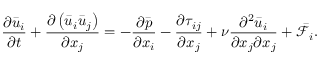<formula> <loc_0><loc_0><loc_500><loc_500>\frac { \partial { { { \bar { u } } } _ { i } } } { \partial t } + \frac { \partial \left ( { { { \bar { u } } } _ { i } } { { { \bar { u } } } _ { j } } \right ) } { \partial { { x } _ { j } } } = - \frac { \partial \bar { p } } { \partial { { x } _ { i } } } - \frac { \partial { { \tau } _ { i j } } } { \partial { { x } _ { j } } } + \nu \frac { { { \partial } ^ { 2 } } { { { \bar { u } } } _ { i } } } { \partial { { x } _ { j } } \partial { { x } _ { j } } } + { { \bar { \mathcal { F } } } _ { i } } .</formula> 